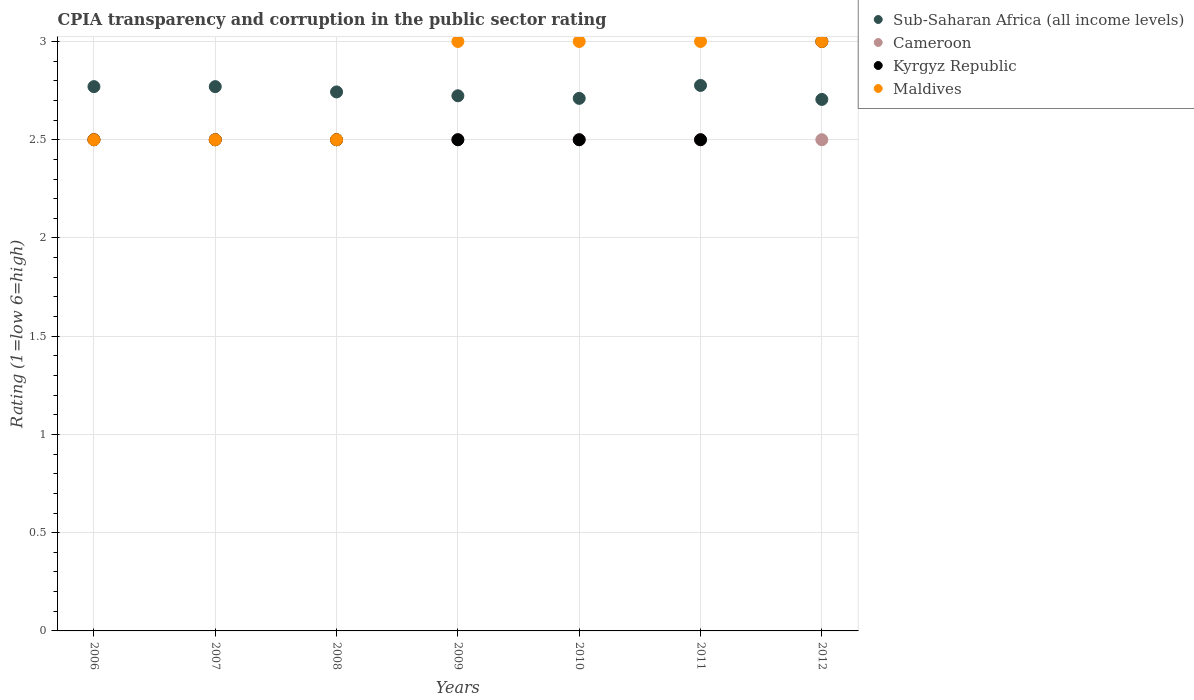How many different coloured dotlines are there?
Provide a succinct answer. 4. Is the number of dotlines equal to the number of legend labels?
Your response must be concise. Yes. Across all years, what is the minimum CPIA rating in Cameroon?
Give a very brief answer. 2.5. What is the total CPIA rating in Maldives in the graph?
Make the answer very short. 19.5. What is the difference between the CPIA rating in Sub-Saharan Africa (all income levels) in 2009 and that in 2012?
Your answer should be very brief. 0.02. What is the average CPIA rating in Sub-Saharan Africa (all income levels) per year?
Ensure brevity in your answer.  2.74. In the year 2006, what is the difference between the CPIA rating in Sub-Saharan Africa (all income levels) and CPIA rating in Maldives?
Give a very brief answer. 0.27. In how many years, is the CPIA rating in Cameroon greater than 0.1?
Offer a very short reply. 7. Is the CPIA rating in Maldives in 2006 less than that in 2009?
Provide a succinct answer. Yes. Is the difference between the CPIA rating in Sub-Saharan Africa (all income levels) in 2010 and 2012 greater than the difference between the CPIA rating in Maldives in 2010 and 2012?
Make the answer very short. Yes. What is the difference between the highest and the lowest CPIA rating in Maldives?
Offer a terse response. 0.5. Is it the case that in every year, the sum of the CPIA rating in Cameroon and CPIA rating in Maldives  is greater than the sum of CPIA rating in Kyrgyz Republic and CPIA rating in Sub-Saharan Africa (all income levels)?
Make the answer very short. No. Is it the case that in every year, the sum of the CPIA rating in Maldives and CPIA rating in Cameroon  is greater than the CPIA rating in Sub-Saharan Africa (all income levels)?
Give a very brief answer. Yes. Does the CPIA rating in Kyrgyz Republic monotonically increase over the years?
Keep it short and to the point. No. Is the CPIA rating in Maldives strictly greater than the CPIA rating in Kyrgyz Republic over the years?
Provide a short and direct response. No. Does the graph contain grids?
Offer a very short reply. Yes. Where does the legend appear in the graph?
Give a very brief answer. Top right. What is the title of the graph?
Offer a terse response. CPIA transparency and corruption in the public sector rating. What is the label or title of the Y-axis?
Your response must be concise. Rating (1=low 6=high). What is the Rating (1=low 6=high) in Sub-Saharan Africa (all income levels) in 2006?
Offer a terse response. 2.77. What is the Rating (1=low 6=high) of Cameroon in 2006?
Your answer should be very brief. 2.5. What is the Rating (1=low 6=high) of Kyrgyz Republic in 2006?
Your answer should be compact. 2.5. What is the Rating (1=low 6=high) in Maldives in 2006?
Your response must be concise. 2.5. What is the Rating (1=low 6=high) of Sub-Saharan Africa (all income levels) in 2007?
Your answer should be very brief. 2.77. What is the Rating (1=low 6=high) in Cameroon in 2007?
Offer a very short reply. 2.5. What is the Rating (1=low 6=high) in Sub-Saharan Africa (all income levels) in 2008?
Offer a terse response. 2.74. What is the Rating (1=low 6=high) of Kyrgyz Republic in 2008?
Your answer should be very brief. 2.5. What is the Rating (1=low 6=high) in Maldives in 2008?
Provide a succinct answer. 2.5. What is the Rating (1=low 6=high) in Sub-Saharan Africa (all income levels) in 2009?
Ensure brevity in your answer.  2.72. What is the Rating (1=low 6=high) in Kyrgyz Republic in 2009?
Offer a terse response. 2.5. What is the Rating (1=low 6=high) of Maldives in 2009?
Make the answer very short. 3. What is the Rating (1=low 6=high) in Sub-Saharan Africa (all income levels) in 2010?
Ensure brevity in your answer.  2.71. What is the Rating (1=low 6=high) in Cameroon in 2010?
Keep it short and to the point. 2.5. What is the Rating (1=low 6=high) of Maldives in 2010?
Provide a short and direct response. 3. What is the Rating (1=low 6=high) of Sub-Saharan Africa (all income levels) in 2011?
Ensure brevity in your answer.  2.78. What is the Rating (1=low 6=high) of Cameroon in 2011?
Ensure brevity in your answer.  2.5. What is the Rating (1=low 6=high) in Kyrgyz Republic in 2011?
Offer a very short reply. 2.5. What is the Rating (1=low 6=high) in Sub-Saharan Africa (all income levels) in 2012?
Your answer should be very brief. 2.71. Across all years, what is the maximum Rating (1=low 6=high) in Sub-Saharan Africa (all income levels)?
Ensure brevity in your answer.  2.78. Across all years, what is the maximum Rating (1=low 6=high) of Maldives?
Offer a terse response. 3. Across all years, what is the minimum Rating (1=low 6=high) in Sub-Saharan Africa (all income levels)?
Provide a short and direct response. 2.71. Across all years, what is the minimum Rating (1=low 6=high) of Cameroon?
Your answer should be very brief. 2.5. Across all years, what is the minimum Rating (1=low 6=high) in Kyrgyz Republic?
Your answer should be very brief. 2.5. Across all years, what is the minimum Rating (1=low 6=high) of Maldives?
Provide a short and direct response. 2.5. What is the total Rating (1=low 6=high) in Sub-Saharan Africa (all income levels) in the graph?
Provide a short and direct response. 19.2. What is the total Rating (1=low 6=high) in Maldives in the graph?
Provide a short and direct response. 19.5. What is the difference between the Rating (1=low 6=high) in Sub-Saharan Africa (all income levels) in 2006 and that in 2007?
Offer a terse response. 0. What is the difference between the Rating (1=low 6=high) of Cameroon in 2006 and that in 2007?
Keep it short and to the point. 0. What is the difference between the Rating (1=low 6=high) of Maldives in 2006 and that in 2007?
Your answer should be compact. 0. What is the difference between the Rating (1=low 6=high) of Sub-Saharan Africa (all income levels) in 2006 and that in 2008?
Make the answer very short. 0.03. What is the difference between the Rating (1=low 6=high) of Cameroon in 2006 and that in 2008?
Keep it short and to the point. 0. What is the difference between the Rating (1=low 6=high) of Kyrgyz Republic in 2006 and that in 2008?
Provide a short and direct response. 0. What is the difference between the Rating (1=low 6=high) of Sub-Saharan Africa (all income levels) in 2006 and that in 2009?
Your answer should be compact. 0.05. What is the difference between the Rating (1=low 6=high) in Cameroon in 2006 and that in 2009?
Provide a succinct answer. 0. What is the difference between the Rating (1=low 6=high) of Kyrgyz Republic in 2006 and that in 2009?
Give a very brief answer. 0. What is the difference between the Rating (1=low 6=high) in Maldives in 2006 and that in 2009?
Your response must be concise. -0.5. What is the difference between the Rating (1=low 6=high) of Sub-Saharan Africa (all income levels) in 2006 and that in 2010?
Provide a succinct answer. 0.06. What is the difference between the Rating (1=low 6=high) in Cameroon in 2006 and that in 2010?
Offer a terse response. 0. What is the difference between the Rating (1=low 6=high) in Kyrgyz Republic in 2006 and that in 2010?
Offer a very short reply. 0. What is the difference between the Rating (1=low 6=high) of Sub-Saharan Africa (all income levels) in 2006 and that in 2011?
Provide a short and direct response. -0.01. What is the difference between the Rating (1=low 6=high) of Cameroon in 2006 and that in 2011?
Your answer should be very brief. 0. What is the difference between the Rating (1=low 6=high) in Kyrgyz Republic in 2006 and that in 2011?
Ensure brevity in your answer.  0. What is the difference between the Rating (1=low 6=high) in Sub-Saharan Africa (all income levels) in 2006 and that in 2012?
Offer a very short reply. 0.07. What is the difference between the Rating (1=low 6=high) in Kyrgyz Republic in 2006 and that in 2012?
Your answer should be very brief. -0.5. What is the difference between the Rating (1=low 6=high) in Maldives in 2006 and that in 2012?
Offer a very short reply. -0.5. What is the difference between the Rating (1=low 6=high) of Sub-Saharan Africa (all income levels) in 2007 and that in 2008?
Keep it short and to the point. 0.03. What is the difference between the Rating (1=low 6=high) of Kyrgyz Republic in 2007 and that in 2008?
Ensure brevity in your answer.  0. What is the difference between the Rating (1=low 6=high) in Maldives in 2007 and that in 2008?
Offer a terse response. 0. What is the difference between the Rating (1=low 6=high) in Sub-Saharan Africa (all income levels) in 2007 and that in 2009?
Your answer should be compact. 0.05. What is the difference between the Rating (1=low 6=high) of Maldives in 2007 and that in 2009?
Give a very brief answer. -0.5. What is the difference between the Rating (1=low 6=high) in Sub-Saharan Africa (all income levels) in 2007 and that in 2010?
Ensure brevity in your answer.  0.06. What is the difference between the Rating (1=low 6=high) in Kyrgyz Republic in 2007 and that in 2010?
Offer a terse response. 0. What is the difference between the Rating (1=low 6=high) in Sub-Saharan Africa (all income levels) in 2007 and that in 2011?
Your answer should be compact. -0.01. What is the difference between the Rating (1=low 6=high) of Maldives in 2007 and that in 2011?
Offer a very short reply. -0.5. What is the difference between the Rating (1=low 6=high) of Sub-Saharan Africa (all income levels) in 2007 and that in 2012?
Your response must be concise. 0.07. What is the difference between the Rating (1=low 6=high) of Cameroon in 2007 and that in 2012?
Offer a terse response. 0. What is the difference between the Rating (1=low 6=high) of Sub-Saharan Africa (all income levels) in 2008 and that in 2009?
Offer a terse response. 0.02. What is the difference between the Rating (1=low 6=high) in Cameroon in 2008 and that in 2009?
Ensure brevity in your answer.  0. What is the difference between the Rating (1=low 6=high) of Sub-Saharan Africa (all income levels) in 2008 and that in 2010?
Provide a succinct answer. 0.03. What is the difference between the Rating (1=low 6=high) in Cameroon in 2008 and that in 2010?
Provide a succinct answer. 0. What is the difference between the Rating (1=low 6=high) in Kyrgyz Republic in 2008 and that in 2010?
Offer a very short reply. 0. What is the difference between the Rating (1=low 6=high) of Sub-Saharan Africa (all income levels) in 2008 and that in 2011?
Your response must be concise. -0.03. What is the difference between the Rating (1=low 6=high) in Sub-Saharan Africa (all income levels) in 2008 and that in 2012?
Offer a very short reply. 0.04. What is the difference between the Rating (1=low 6=high) in Kyrgyz Republic in 2008 and that in 2012?
Offer a terse response. -0.5. What is the difference between the Rating (1=low 6=high) in Sub-Saharan Africa (all income levels) in 2009 and that in 2010?
Your response must be concise. 0.01. What is the difference between the Rating (1=low 6=high) of Sub-Saharan Africa (all income levels) in 2009 and that in 2011?
Your response must be concise. -0.05. What is the difference between the Rating (1=low 6=high) in Cameroon in 2009 and that in 2011?
Keep it short and to the point. 0. What is the difference between the Rating (1=low 6=high) of Kyrgyz Republic in 2009 and that in 2011?
Ensure brevity in your answer.  0. What is the difference between the Rating (1=low 6=high) of Maldives in 2009 and that in 2011?
Provide a short and direct response. 0. What is the difference between the Rating (1=low 6=high) in Sub-Saharan Africa (all income levels) in 2009 and that in 2012?
Your answer should be very brief. 0.02. What is the difference between the Rating (1=low 6=high) in Cameroon in 2009 and that in 2012?
Provide a succinct answer. 0. What is the difference between the Rating (1=low 6=high) in Kyrgyz Republic in 2009 and that in 2012?
Provide a short and direct response. -0.5. What is the difference between the Rating (1=low 6=high) of Sub-Saharan Africa (all income levels) in 2010 and that in 2011?
Give a very brief answer. -0.07. What is the difference between the Rating (1=low 6=high) of Sub-Saharan Africa (all income levels) in 2010 and that in 2012?
Your response must be concise. 0.01. What is the difference between the Rating (1=low 6=high) in Cameroon in 2010 and that in 2012?
Your answer should be compact. 0. What is the difference between the Rating (1=low 6=high) of Kyrgyz Republic in 2010 and that in 2012?
Offer a terse response. -0.5. What is the difference between the Rating (1=low 6=high) of Sub-Saharan Africa (all income levels) in 2011 and that in 2012?
Offer a terse response. 0.07. What is the difference between the Rating (1=low 6=high) in Sub-Saharan Africa (all income levels) in 2006 and the Rating (1=low 6=high) in Cameroon in 2007?
Your answer should be very brief. 0.27. What is the difference between the Rating (1=low 6=high) of Sub-Saharan Africa (all income levels) in 2006 and the Rating (1=low 6=high) of Kyrgyz Republic in 2007?
Provide a succinct answer. 0.27. What is the difference between the Rating (1=low 6=high) in Sub-Saharan Africa (all income levels) in 2006 and the Rating (1=low 6=high) in Maldives in 2007?
Provide a succinct answer. 0.27. What is the difference between the Rating (1=low 6=high) of Cameroon in 2006 and the Rating (1=low 6=high) of Kyrgyz Republic in 2007?
Ensure brevity in your answer.  0. What is the difference between the Rating (1=low 6=high) in Sub-Saharan Africa (all income levels) in 2006 and the Rating (1=low 6=high) in Cameroon in 2008?
Offer a terse response. 0.27. What is the difference between the Rating (1=low 6=high) in Sub-Saharan Africa (all income levels) in 2006 and the Rating (1=low 6=high) in Kyrgyz Republic in 2008?
Keep it short and to the point. 0.27. What is the difference between the Rating (1=low 6=high) in Sub-Saharan Africa (all income levels) in 2006 and the Rating (1=low 6=high) in Maldives in 2008?
Your answer should be very brief. 0.27. What is the difference between the Rating (1=low 6=high) in Sub-Saharan Africa (all income levels) in 2006 and the Rating (1=low 6=high) in Cameroon in 2009?
Offer a terse response. 0.27. What is the difference between the Rating (1=low 6=high) in Sub-Saharan Africa (all income levels) in 2006 and the Rating (1=low 6=high) in Kyrgyz Republic in 2009?
Your answer should be compact. 0.27. What is the difference between the Rating (1=low 6=high) of Sub-Saharan Africa (all income levels) in 2006 and the Rating (1=low 6=high) of Maldives in 2009?
Your response must be concise. -0.23. What is the difference between the Rating (1=low 6=high) in Sub-Saharan Africa (all income levels) in 2006 and the Rating (1=low 6=high) in Cameroon in 2010?
Make the answer very short. 0.27. What is the difference between the Rating (1=low 6=high) of Sub-Saharan Africa (all income levels) in 2006 and the Rating (1=low 6=high) of Kyrgyz Republic in 2010?
Ensure brevity in your answer.  0.27. What is the difference between the Rating (1=low 6=high) in Sub-Saharan Africa (all income levels) in 2006 and the Rating (1=low 6=high) in Maldives in 2010?
Keep it short and to the point. -0.23. What is the difference between the Rating (1=low 6=high) in Cameroon in 2006 and the Rating (1=low 6=high) in Kyrgyz Republic in 2010?
Ensure brevity in your answer.  0. What is the difference between the Rating (1=low 6=high) in Kyrgyz Republic in 2006 and the Rating (1=low 6=high) in Maldives in 2010?
Keep it short and to the point. -0.5. What is the difference between the Rating (1=low 6=high) of Sub-Saharan Africa (all income levels) in 2006 and the Rating (1=low 6=high) of Cameroon in 2011?
Offer a very short reply. 0.27. What is the difference between the Rating (1=low 6=high) of Sub-Saharan Africa (all income levels) in 2006 and the Rating (1=low 6=high) of Kyrgyz Republic in 2011?
Your response must be concise. 0.27. What is the difference between the Rating (1=low 6=high) in Sub-Saharan Africa (all income levels) in 2006 and the Rating (1=low 6=high) in Maldives in 2011?
Your answer should be compact. -0.23. What is the difference between the Rating (1=low 6=high) of Cameroon in 2006 and the Rating (1=low 6=high) of Kyrgyz Republic in 2011?
Offer a terse response. 0. What is the difference between the Rating (1=low 6=high) in Cameroon in 2006 and the Rating (1=low 6=high) in Maldives in 2011?
Your answer should be very brief. -0.5. What is the difference between the Rating (1=low 6=high) in Sub-Saharan Africa (all income levels) in 2006 and the Rating (1=low 6=high) in Cameroon in 2012?
Provide a succinct answer. 0.27. What is the difference between the Rating (1=low 6=high) of Sub-Saharan Africa (all income levels) in 2006 and the Rating (1=low 6=high) of Kyrgyz Republic in 2012?
Offer a terse response. -0.23. What is the difference between the Rating (1=low 6=high) of Sub-Saharan Africa (all income levels) in 2006 and the Rating (1=low 6=high) of Maldives in 2012?
Your answer should be compact. -0.23. What is the difference between the Rating (1=low 6=high) of Cameroon in 2006 and the Rating (1=low 6=high) of Kyrgyz Republic in 2012?
Make the answer very short. -0.5. What is the difference between the Rating (1=low 6=high) of Sub-Saharan Africa (all income levels) in 2007 and the Rating (1=low 6=high) of Cameroon in 2008?
Ensure brevity in your answer.  0.27. What is the difference between the Rating (1=low 6=high) of Sub-Saharan Africa (all income levels) in 2007 and the Rating (1=low 6=high) of Kyrgyz Republic in 2008?
Your answer should be very brief. 0.27. What is the difference between the Rating (1=low 6=high) of Sub-Saharan Africa (all income levels) in 2007 and the Rating (1=low 6=high) of Maldives in 2008?
Make the answer very short. 0.27. What is the difference between the Rating (1=low 6=high) of Cameroon in 2007 and the Rating (1=low 6=high) of Maldives in 2008?
Provide a succinct answer. 0. What is the difference between the Rating (1=low 6=high) in Sub-Saharan Africa (all income levels) in 2007 and the Rating (1=low 6=high) in Cameroon in 2009?
Your answer should be very brief. 0.27. What is the difference between the Rating (1=low 6=high) of Sub-Saharan Africa (all income levels) in 2007 and the Rating (1=low 6=high) of Kyrgyz Republic in 2009?
Your response must be concise. 0.27. What is the difference between the Rating (1=low 6=high) of Sub-Saharan Africa (all income levels) in 2007 and the Rating (1=low 6=high) of Maldives in 2009?
Your answer should be compact. -0.23. What is the difference between the Rating (1=low 6=high) of Sub-Saharan Africa (all income levels) in 2007 and the Rating (1=low 6=high) of Cameroon in 2010?
Ensure brevity in your answer.  0.27. What is the difference between the Rating (1=low 6=high) of Sub-Saharan Africa (all income levels) in 2007 and the Rating (1=low 6=high) of Kyrgyz Republic in 2010?
Provide a succinct answer. 0.27. What is the difference between the Rating (1=low 6=high) in Sub-Saharan Africa (all income levels) in 2007 and the Rating (1=low 6=high) in Maldives in 2010?
Your answer should be compact. -0.23. What is the difference between the Rating (1=low 6=high) in Cameroon in 2007 and the Rating (1=low 6=high) in Kyrgyz Republic in 2010?
Your answer should be compact. 0. What is the difference between the Rating (1=low 6=high) in Kyrgyz Republic in 2007 and the Rating (1=low 6=high) in Maldives in 2010?
Offer a very short reply. -0.5. What is the difference between the Rating (1=low 6=high) in Sub-Saharan Africa (all income levels) in 2007 and the Rating (1=low 6=high) in Cameroon in 2011?
Your response must be concise. 0.27. What is the difference between the Rating (1=low 6=high) in Sub-Saharan Africa (all income levels) in 2007 and the Rating (1=low 6=high) in Kyrgyz Republic in 2011?
Give a very brief answer. 0.27. What is the difference between the Rating (1=low 6=high) of Sub-Saharan Africa (all income levels) in 2007 and the Rating (1=low 6=high) of Maldives in 2011?
Offer a very short reply. -0.23. What is the difference between the Rating (1=low 6=high) of Cameroon in 2007 and the Rating (1=low 6=high) of Kyrgyz Republic in 2011?
Provide a succinct answer. 0. What is the difference between the Rating (1=low 6=high) of Kyrgyz Republic in 2007 and the Rating (1=low 6=high) of Maldives in 2011?
Your answer should be very brief. -0.5. What is the difference between the Rating (1=low 6=high) of Sub-Saharan Africa (all income levels) in 2007 and the Rating (1=low 6=high) of Cameroon in 2012?
Your answer should be compact. 0.27. What is the difference between the Rating (1=low 6=high) in Sub-Saharan Africa (all income levels) in 2007 and the Rating (1=low 6=high) in Kyrgyz Republic in 2012?
Offer a very short reply. -0.23. What is the difference between the Rating (1=low 6=high) of Sub-Saharan Africa (all income levels) in 2007 and the Rating (1=low 6=high) of Maldives in 2012?
Ensure brevity in your answer.  -0.23. What is the difference between the Rating (1=low 6=high) in Cameroon in 2007 and the Rating (1=low 6=high) in Kyrgyz Republic in 2012?
Your answer should be very brief. -0.5. What is the difference between the Rating (1=low 6=high) in Cameroon in 2007 and the Rating (1=low 6=high) in Maldives in 2012?
Provide a succinct answer. -0.5. What is the difference between the Rating (1=low 6=high) of Sub-Saharan Africa (all income levels) in 2008 and the Rating (1=low 6=high) of Cameroon in 2009?
Your answer should be compact. 0.24. What is the difference between the Rating (1=low 6=high) in Sub-Saharan Africa (all income levels) in 2008 and the Rating (1=low 6=high) in Kyrgyz Republic in 2009?
Keep it short and to the point. 0.24. What is the difference between the Rating (1=low 6=high) in Sub-Saharan Africa (all income levels) in 2008 and the Rating (1=low 6=high) in Maldives in 2009?
Give a very brief answer. -0.26. What is the difference between the Rating (1=low 6=high) of Cameroon in 2008 and the Rating (1=low 6=high) of Maldives in 2009?
Your answer should be compact. -0.5. What is the difference between the Rating (1=low 6=high) of Sub-Saharan Africa (all income levels) in 2008 and the Rating (1=low 6=high) of Cameroon in 2010?
Your answer should be compact. 0.24. What is the difference between the Rating (1=low 6=high) in Sub-Saharan Africa (all income levels) in 2008 and the Rating (1=low 6=high) in Kyrgyz Republic in 2010?
Ensure brevity in your answer.  0.24. What is the difference between the Rating (1=low 6=high) in Sub-Saharan Africa (all income levels) in 2008 and the Rating (1=low 6=high) in Maldives in 2010?
Provide a succinct answer. -0.26. What is the difference between the Rating (1=low 6=high) of Sub-Saharan Africa (all income levels) in 2008 and the Rating (1=low 6=high) of Cameroon in 2011?
Ensure brevity in your answer.  0.24. What is the difference between the Rating (1=low 6=high) in Sub-Saharan Africa (all income levels) in 2008 and the Rating (1=low 6=high) in Kyrgyz Republic in 2011?
Offer a terse response. 0.24. What is the difference between the Rating (1=low 6=high) in Sub-Saharan Africa (all income levels) in 2008 and the Rating (1=low 6=high) in Maldives in 2011?
Make the answer very short. -0.26. What is the difference between the Rating (1=low 6=high) in Cameroon in 2008 and the Rating (1=low 6=high) in Kyrgyz Republic in 2011?
Make the answer very short. 0. What is the difference between the Rating (1=low 6=high) of Cameroon in 2008 and the Rating (1=low 6=high) of Maldives in 2011?
Keep it short and to the point. -0.5. What is the difference between the Rating (1=low 6=high) in Kyrgyz Republic in 2008 and the Rating (1=low 6=high) in Maldives in 2011?
Provide a short and direct response. -0.5. What is the difference between the Rating (1=low 6=high) of Sub-Saharan Africa (all income levels) in 2008 and the Rating (1=low 6=high) of Cameroon in 2012?
Offer a very short reply. 0.24. What is the difference between the Rating (1=low 6=high) in Sub-Saharan Africa (all income levels) in 2008 and the Rating (1=low 6=high) in Kyrgyz Republic in 2012?
Provide a succinct answer. -0.26. What is the difference between the Rating (1=low 6=high) of Sub-Saharan Africa (all income levels) in 2008 and the Rating (1=low 6=high) of Maldives in 2012?
Offer a very short reply. -0.26. What is the difference between the Rating (1=low 6=high) in Cameroon in 2008 and the Rating (1=low 6=high) in Kyrgyz Republic in 2012?
Make the answer very short. -0.5. What is the difference between the Rating (1=low 6=high) in Sub-Saharan Africa (all income levels) in 2009 and the Rating (1=low 6=high) in Cameroon in 2010?
Keep it short and to the point. 0.22. What is the difference between the Rating (1=low 6=high) of Sub-Saharan Africa (all income levels) in 2009 and the Rating (1=low 6=high) of Kyrgyz Republic in 2010?
Give a very brief answer. 0.22. What is the difference between the Rating (1=low 6=high) of Sub-Saharan Africa (all income levels) in 2009 and the Rating (1=low 6=high) of Maldives in 2010?
Offer a terse response. -0.28. What is the difference between the Rating (1=low 6=high) of Kyrgyz Republic in 2009 and the Rating (1=low 6=high) of Maldives in 2010?
Offer a terse response. -0.5. What is the difference between the Rating (1=low 6=high) of Sub-Saharan Africa (all income levels) in 2009 and the Rating (1=low 6=high) of Cameroon in 2011?
Provide a short and direct response. 0.22. What is the difference between the Rating (1=low 6=high) of Sub-Saharan Africa (all income levels) in 2009 and the Rating (1=low 6=high) of Kyrgyz Republic in 2011?
Provide a short and direct response. 0.22. What is the difference between the Rating (1=low 6=high) of Sub-Saharan Africa (all income levels) in 2009 and the Rating (1=low 6=high) of Maldives in 2011?
Keep it short and to the point. -0.28. What is the difference between the Rating (1=low 6=high) in Sub-Saharan Africa (all income levels) in 2009 and the Rating (1=low 6=high) in Cameroon in 2012?
Your answer should be very brief. 0.22. What is the difference between the Rating (1=low 6=high) in Sub-Saharan Africa (all income levels) in 2009 and the Rating (1=low 6=high) in Kyrgyz Republic in 2012?
Offer a very short reply. -0.28. What is the difference between the Rating (1=low 6=high) in Sub-Saharan Africa (all income levels) in 2009 and the Rating (1=low 6=high) in Maldives in 2012?
Make the answer very short. -0.28. What is the difference between the Rating (1=low 6=high) in Cameroon in 2009 and the Rating (1=low 6=high) in Maldives in 2012?
Make the answer very short. -0.5. What is the difference between the Rating (1=low 6=high) of Kyrgyz Republic in 2009 and the Rating (1=low 6=high) of Maldives in 2012?
Your answer should be very brief. -0.5. What is the difference between the Rating (1=low 6=high) in Sub-Saharan Africa (all income levels) in 2010 and the Rating (1=low 6=high) in Cameroon in 2011?
Your response must be concise. 0.21. What is the difference between the Rating (1=low 6=high) in Sub-Saharan Africa (all income levels) in 2010 and the Rating (1=low 6=high) in Kyrgyz Republic in 2011?
Ensure brevity in your answer.  0.21. What is the difference between the Rating (1=low 6=high) in Sub-Saharan Africa (all income levels) in 2010 and the Rating (1=low 6=high) in Maldives in 2011?
Your response must be concise. -0.29. What is the difference between the Rating (1=low 6=high) in Cameroon in 2010 and the Rating (1=low 6=high) in Kyrgyz Republic in 2011?
Make the answer very short. 0. What is the difference between the Rating (1=low 6=high) in Sub-Saharan Africa (all income levels) in 2010 and the Rating (1=low 6=high) in Cameroon in 2012?
Keep it short and to the point. 0.21. What is the difference between the Rating (1=low 6=high) of Sub-Saharan Africa (all income levels) in 2010 and the Rating (1=low 6=high) of Kyrgyz Republic in 2012?
Offer a very short reply. -0.29. What is the difference between the Rating (1=low 6=high) of Sub-Saharan Africa (all income levels) in 2010 and the Rating (1=low 6=high) of Maldives in 2012?
Give a very brief answer. -0.29. What is the difference between the Rating (1=low 6=high) of Cameroon in 2010 and the Rating (1=low 6=high) of Kyrgyz Republic in 2012?
Offer a very short reply. -0.5. What is the difference between the Rating (1=low 6=high) of Cameroon in 2010 and the Rating (1=low 6=high) of Maldives in 2012?
Your answer should be very brief. -0.5. What is the difference between the Rating (1=low 6=high) of Sub-Saharan Africa (all income levels) in 2011 and the Rating (1=low 6=high) of Cameroon in 2012?
Give a very brief answer. 0.28. What is the difference between the Rating (1=low 6=high) of Sub-Saharan Africa (all income levels) in 2011 and the Rating (1=low 6=high) of Kyrgyz Republic in 2012?
Offer a very short reply. -0.22. What is the difference between the Rating (1=low 6=high) of Sub-Saharan Africa (all income levels) in 2011 and the Rating (1=low 6=high) of Maldives in 2012?
Offer a very short reply. -0.22. What is the difference between the Rating (1=low 6=high) of Kyrgyz Republic in 2011 and the Rating (1=low 6=high) of Maldives in 2012?
Your response must be concise. -0.5. What is the average Rating (1=low 6=high) of Sub-Saharan Africa (all income levels) per year?
Offer a very short reply. 2.74. What is the average Rating (1=low 6=high) of Kyrgyz Republic per year?
Ensure brevity in your answer.  2.57. What is the average Rating (1=low 6=high) of Maldives per year?
Your answer should be very brief. 2.79. In the year 2006, what is the difference between the Rating (1=low 6=high) in Sub-Saharan Africa (all income levels) and Rating (1=low 6=high) in Cameroon?
Ensure brevity in your answer.  0.27. In the year 2006, what is the difference between the Rating (1=low 6=high) of Sub-Saharan Africa (all income levels) and Rating (1=low 6=high) of Kyrgyz Republic?
Give a very brief answer. 0.27. In the year 2006, what is the difference between the Rating (1=low 6=high) of Sub-Saharan Africa (all income levels) and Rating (1=low 6=high) of Maldives?
Offer a very short reply. 0.27. In the year 2006, what is the difference between the Rating (1=low 6=high) in Cameroon and Rating (1=low 6=high) in Kyrgyz Republic?
Provide a short and direct response. 0. In the year 2006, what is the difference between the Rating (1=low 6=high) in Cameroon and Rating (1=low 6=high) in Maldives?
Provide a succinct answer. 0. In the year 2006, what is the difference between the Rating (1=low 6=high) of Kyrgyz Republic and Rating (1=low 6=high) of Maldives?
Offer a very short reply. 0. In the year 2007, what is the difference between the Rating (1=low 6=high) of Sub-Saharan Africa (all income levels) and Rating (1=low 6=high) of Cameroon?
Provide a succinct answer. 0.27. In the year 2007, what is the difference between the Rating (1=low 6=high) in Sub-Saharan Africa (all income levels) and Rating (1=low 6=high) in Kyrgyz Republic?
Make the answer very short. 0.27. In the year 2007, what is the difference between the Rating (1=low 6=high) of Sub-Saharan Africa (all income levels) and Rating (1=low 6=high) of Maldives?
Give a very brief answer. 0.27. In the year 2007, what is the difference between the Rating (1=low 6=high) in Cameroon and Rating (1=low 6=high) in Kyrgyz Republic?
Your response must be concise. 0. In the year 2007, what is the difference between the Rating (1=low 6=high) of Kyrgyz Republic and Rating (1=low 6=high) of Maldives?
Ensure brevity in your answer.  0. In the year 2008, what is the difference between the Rating (1=low 6=high) of Sub-Saharan Africa (all income levels) and Rating (1=low 6=high) of Cameroon?
Your answer should be very brief. 0.24. In the year 2008, what is the difference between the Rating (1=low 6=high) in Sub-Saharan Africa (all income levels) and Rating (1=low 6=high) in Kyrgyz Republic?
Offer a terse response. 0.24. In the year 2008, what is the difference between the Rating (1=low 6=high) of Sub-Saharan Africa (all income levels) and Rating (1=low 6=high) of Maldives?
Give a very brief answer. 0.24. In the year 2008, what is the difference between the Rating (1=low 6=high) of Cameroon and Rating (1=low 6=high) of Kyrgyz Republic?
Your response must be concise. 0. In the year 2008, what is the difference between the Rating (1=low 6=high) of Cameroon and Rating (1=low 6=high) of Maldives?
Your answer should be compact. 0. In the year 2009, what is the difference between the Rating (1=low 6=high) in Sub-Saharan Africa (all income levels) and Rating (1=low 6=high) in Cameroon?
Your response must be concise. 0.22. In the year 2009, what is the difference between the Rating (1=low 6=high) of Sub-Saharan Africa (all income levels) and Rating (1=low 6=high) of Kyrgyz Republic?
Provide a short and direct response. 0.22. In the year 2009, what is the difference between the Rating (1=low 6=high) of Sub-Saharan Africa (all income levels) and Rating (1=low 6=high) of Maldives?
Your response must be concise. -0.28. In the year 2009, what is the difference between the Rating (1=low 6=high) of Cameroon and Rating (1=low 6=high) of Kyrgyz Republic?
Provide a succinct answer. 0. In the year 2009, what is the difference between the Rating (1=low 6=high) in Kyrgyz Republic and Rating (1=low 6=high) in Maldives?
Make the answer very short. -0.5. In the year 2010, what is the difference between the Rating (1=low 6=high) in Sub-Saharan Africa (all income levels) and Rating (1=low 6=high) in Cameroon?
Make the answer very short. 0.21. In the year 2010, what is the difference between the Rating (1=low 6=high) in Sub-Saharan Africa (all income levels) and Rating (1=low 6=high) in Kyrgyz Republic?
Offer a very short reply. 0.21. In the year 2010, what is the difference between the Rating (1=low 6=high) of Sub-Saharan Africa (all income levels) and Rating (1=low 6=high) of Maldives?
Provide a succinct answer. -0.29. In the year 2010, what is the difference between the Rating (1=low 6=high) in Cameroon and Rating (1=low 6=high) in Kyrgyz Republic?
Your response must be concise. 0. In the year 2010, what is the difference between the Rating (1=low 6=high) in Cameroon and Rating (1=low 6=high) in Maldives?
Give a very brief answer. -0.5. In the year 2010, what is the difference between the Rating (1=low 6=high) in Kyrgyz Republic and Rating (1=low 6=high) in Maldives?
Your answer should be very brief. -0.5. In the year 2011, what is the difference between the Rating (1=low 6=high) of Sub-Saharan Africa (all income levels) and Rating (1=low 6=high) of Cameroon?
Provide a succinct answer. 0.28. In the year 2011, what is the difference between the Rating (1=low 6=high) in Sub-Saharan Africa (all income levels) and Rating (1=low 6=high) in Kyrgyz Republic?
Offer a terse response. 0.28. In the year 2011, what is the difference between the Rating (1=low 6=high) in Sub-Saharan Africa (all income levels) and Rating (1=low 6=high) in Maldives?
Make the answer very short. -0.22. In the year 2011, what is the difference between the Rating (1=low 6=high) in Kyrgyz Republic and Rating (1=low 6=high) in Maldives?
Provide a succinct answer. -0.5. In the year 2012, what is the difference between the Rating (1=low 6=high) in Sub-Saharan Africa (all income levels) and Rating (1=low 6=high) in Cameroon?
Give a very brief answer. 0.21. In the year 2012, what is the difference between the Rating (1=low 6=high) of Sub-Saharan Africa (all income levels) and Rating (1=low 6=high) of Kyrgyz Republic?
Your response must be concise. -0.29. In the year 2012, what is the difference between the Rating (1=low 6=high) in Sub-Saharan Africa (all income levels) and Rating (1=low 6=high) in Maldives?
Ensure brevity in your answer.  -0.29. In the year 2012, what is the difference between the Rating (1=low 6=high) of Cameroon and Rating (1=low 6=high) of Kyrgyz Republic?
Ensure brevity in your answer.  -0.5. In the year 2012, what is the difference between the Rating (1=low 6=high) in Cameroon and Rating (1=low 6=high) in Maldives?
Ensure brevity in your answer.  -0.5. What is the ratio of the Rating (1=low 6=high) of Kyrgyz Republic in 2006 to that in 2007?
Give a very brief answer. 1. What is the ratio of the Rating (1=low 6=high) of Sub-Saharan Africa (all income levels) in 2006 to that in 2008?
Ensure brevity in your answer.  1.01. What is the ratio of the Rating (1=low 6=high) in Sub-Saharan Africa (all income levels) in 2006 to that in 2009?
Offer a terse response. 1.02. What is the ratio of the Rating (1=low 6=high) in Cameroon in 2006 to that in 2009?
Keep it short and to the point. 1. What is the ratio of the Rating (1=low 6=high) in Sub-Saharan Africa (all income levels) in 2006 to that in 2010?
Make the answer very short. 1.02. What is the ratio of the Rating (1=low 6=high) in Cameroon in 2006 to that in 2010?
Provide a succinct answer. 1. What is the ratio of the Rating (1=low 6=high) in Kyrgyz Republic in 2006 to that in 2010?
Give a very brief answer. 1. What is the ratio of the Rating (1=low 6=high) in Maldives in 2006 to that in 2010?
Your answer should be compact. 0.83. What is the ratio of the Rating (1=low 6=high) in Sub-Saharan Africa (all income levels) in 2006 to that in 2012?
Ensure brevity in your answer.  1.02. What is the ratio of the Rating (1=low 6=high) in Cameroon in 2006 to that in 2012?
Your answer should be compact. 1. What is the ratio of the Rating (1=low 6=high) in Sub-Saharan Africa (all income levels) in 2007 to that in 2008?
Give a very brief answer. 1.01. What is the ratio of the Rating (1=low 6=high) in Sub-Saharan Africa (all income levels) in 2007 to that in 2009?
Provide a short and direct response. 1.02. What is the ratio of the Rating (1=low 6=high) of Cameroon in 2007 to that in 2009?
Provide a short and direct response. 1. What is the ratio of the Rating (1=low 6=high) of Maldives in 2007 to that in 2009?
Keep it short and to the point. 0.83. What is the ratio of the Rating (1=low 6=high) of Sub-Saharan Africa (all income levels) in 2007 to that in 2010?
Your answer should be compact. 1.02. What is the ratio of the Rating (1=low 6=high) of Kyrgyz Republic in 2007 to that in 2010?
Offer a very short reply. 1. What is the ratio of the Rating (1=low 6=high) of Sub-Saharan Africa (all income levels) in 2007 to that in 2011?
Provide a succinct answer. 1. What is the ratio of the Rating (1=low 6=high) of Kyrgyz Republic in 2007 to that in 2011?
Your response must be concise. 1. What is the ratio of the Rating (1=low 6=high) of Maldives in 2007 to that in 2011?
Keep it short and to the point. 0.83. What is the ratio of the Rating (1=low 6=high) in Sub-Saharan Africa (all income levels) in 2007 to that in 2012?
Offer a terse response. 1.02. What is the ratio of the Rating (1=low 6=high) in Maldives in 2007 to that in 2012?
Ensure brevity in your answer.  0.83. What is the ratio of the Rating (1=low 6=high) in Sub-Saharan Africa (all income levels) in 2008 to that in 2009?
Provide a short and direct response. 1.01. What is the ratio of the Rating (1=low 6=high) of Kyrgyz Republic in 2008 to that in 2009?
Your response must be concise. 1. What is the ratio of the Rating (1=low 6=high) of Maldives in 2008 to that in 2009?
Your response must be concise. 0.83. What is the ratio of the Rating (1=low 6=high) in Sub-Saharan Africa (all income levels) in 2008 to that in 2010?
Provide a short and direct response. 1.01. What is the ratio of the Rating (1=low 6=high) of Cameroon in 2008 to that in 2010?
Keep it short and to the point. 1. What is the ratio of the Rating (1=low 6=high) in Maldives in 2008 to that in 2010?
Provide a short and direct response. 0.83. What is the ratio of the Rating (1=low 6=high) of Cameroon in 2008 to that in 2011?
Give a very brief answer. 1. What is the ratio of the Rating (1=low 6=high) in Kyrgyz Republic in 2008 to that in 2011?
Offer a terse response. 1. What is the ratio of the Rating (1=low 6=high) in Sub-Saharan Africa (all income levels) in 2008 to that in 2012?
Your answer should be compact. 1.01. What is the ratio of the Rating (1=low 6=high) in Cameroon in 2008 to that in 2012?
Offer a terse response. 1. What is the ratio of the Rating (1=low 6=high) of Sub-Saharan Africa (all income levels) in 2009 to that in 2010?
Provide a short and direct response. 1. What is the ratio of the Rating (1=low 6=high) of Kyrgyz Republic in 2009 to that in 2010?
Offer a very short reply. 1. What is the ratio of the Rating (1=low 6=high) in Maldives in 2009 to that in 2010?
Your answer should be compact. 1. What is the ratio of the Rating (1=low 6=high) in Cameroon in 2009 to that in 2011?
Keep it short and to the point. 1. What is the ratio of the Rating (1=low 6=high) of Maldives in 2009 to that in 2011?
Your answer should be compact. 1. What is the ratio of the Rating (1=low 6=high) in Cameroon in 2009 to that in 2012?
Provide a succinct answer. 1. What is the ratio of the Rating (1=low 6=high) in Kyrgyz Republic in 2009 to that in 2012?
Provide a short and direct response. 0.83. What is the ratio of the Rating (1=low 6=high) of Maldives in 2009 to that in 2012?
Keep it short and to the point. 1. What is the ratio of the Rating (1=low 6=high) of Sub-Saharan Africa (all income levels) in 2010 to that in 2011?
Give a very brief answer. 0.98. What is the ratio of the Rating (1=low 6=high) of Kyrgyz Republic in 2010 to that in 2011?
Your answer should be very brief. 1. What is the ratio of the Rating (1=low 6=high) of Sub-Saharan Africa (all income levels) in 2010 to that in 2012?
Ensure brevity in your answer.  1. What is the ratio of the Rating (1=low 6=high) in Cameroon in 2010 to that in 2012?
Your answer should be compact. 1. What is the ratio of the Rating (1=low 6=high) of Kyrgyz Republic in 2010 to that in 2012?
Offer a very short reply. 0.83. What is the ratio of the Rating (1=low 6=high) in Sub-Saharan Africa (all income levels) in 2011 to that in 2012?
Ensure brevity in your answer.  1.03. What is the ratio of the Rating (1=low 6=high) in Cameroon in 2011 to that in 2012?
Offer a very short reply. 1. What is the ratio of the Rating (1=low 6=high) of Kyrgyz Republic in 2011 to that in 2012?
Make the answer very short. 0.83. What is the difference between the highest and the second highest Rating (1=low 6=high) in Sub-Saharan Africa (all income levels)?
Your answer should be compact. 0.01. What is the difference between the highest and the second highest Rating (1=low 6=high) of Maldives?
Ensure brevity in your answer.  0. What is the difference between the highest and the lowest Rating (1=low 6=high) of Sub-Saharan Africa (all income levels)?
Your answer should be very brief. 0.07. What is the difference between the highest and the lowest Rating (1=low 6=high) of Cameroon?
Make the answer very short. 0. What is the difference between the highest and the lowest Rating (1=low 6=high) of Kyrgyz Republic?
Your response must be concise. 0.5. What is the difference between the highest and the lowest Rating (1=low 6=high) of Maldives?
Offer a terse response. 0.5. 